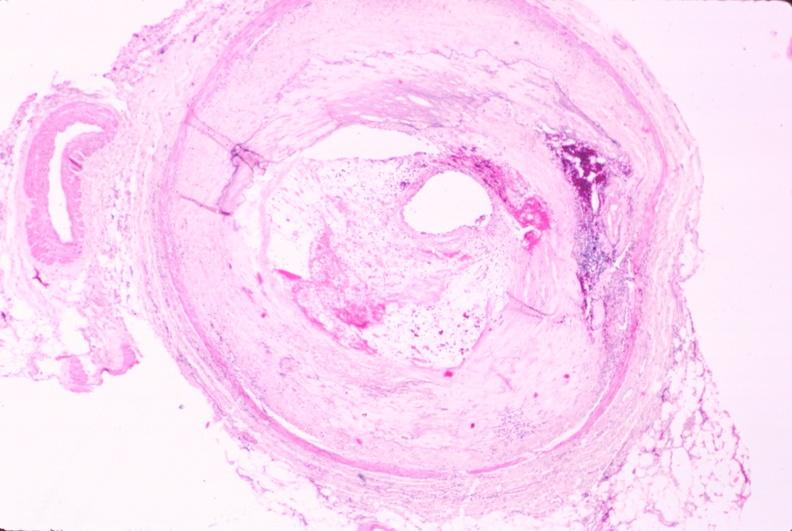s vasculature present?
Answer the question using a single word or phrase. Yes 